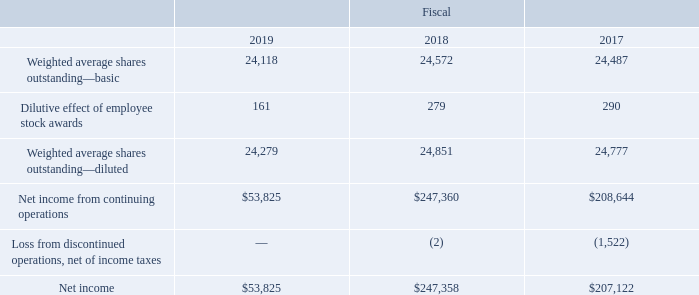Earnings Per Share
Basic earnings per share is computed based on the weighted average number of shares outstanding during the period, excluding unvested restricted stock. Diluted earnings per share is computed based on the weighted average number of shares outstanding during the period increased by the effect of dilutive employee stock awards, including stock options, restricted stock awards and stock purchase plan contracts, using the treasury stock method.
The following table presents information necessary to calculate basic and diluted earnings per share (in thousands, except per share data):
There were 98,103, 103,547 and 505 potentially dilutive securities excluded from the dilutive share calculation for fiscal 2019, 2018 and 2017, respectively, as their effect was anti-dilutive.
How was basic earnings per share computed? Based on the weighted average number of shares outstanding during the period, excluding unvested restricted stock. How was diluted earnings per share computed? Based on the weighted average number of shares outstanding during the period increased by the effect of dilutive employee stock awards, including stock options, restricted stock awards and stock purchase plan contracts, using the treasury stock method. In which years was earnings per share provided in the table? 2019, 2018, 2017. In which year was the Dilutive effect of employee stock awards largest? 290>279>161
Answer: 2017. What was the change in Dilutive effect of employee stock awards in 2019 from 2018?
Answer scale should be: thousand. 161-279
Answer: -118. What was the percentage change in Dilutive effect of employee stock awards in 2019 from 2018?
Answer scale should be: percent. (161-279)/279
Answer: -42.29. 